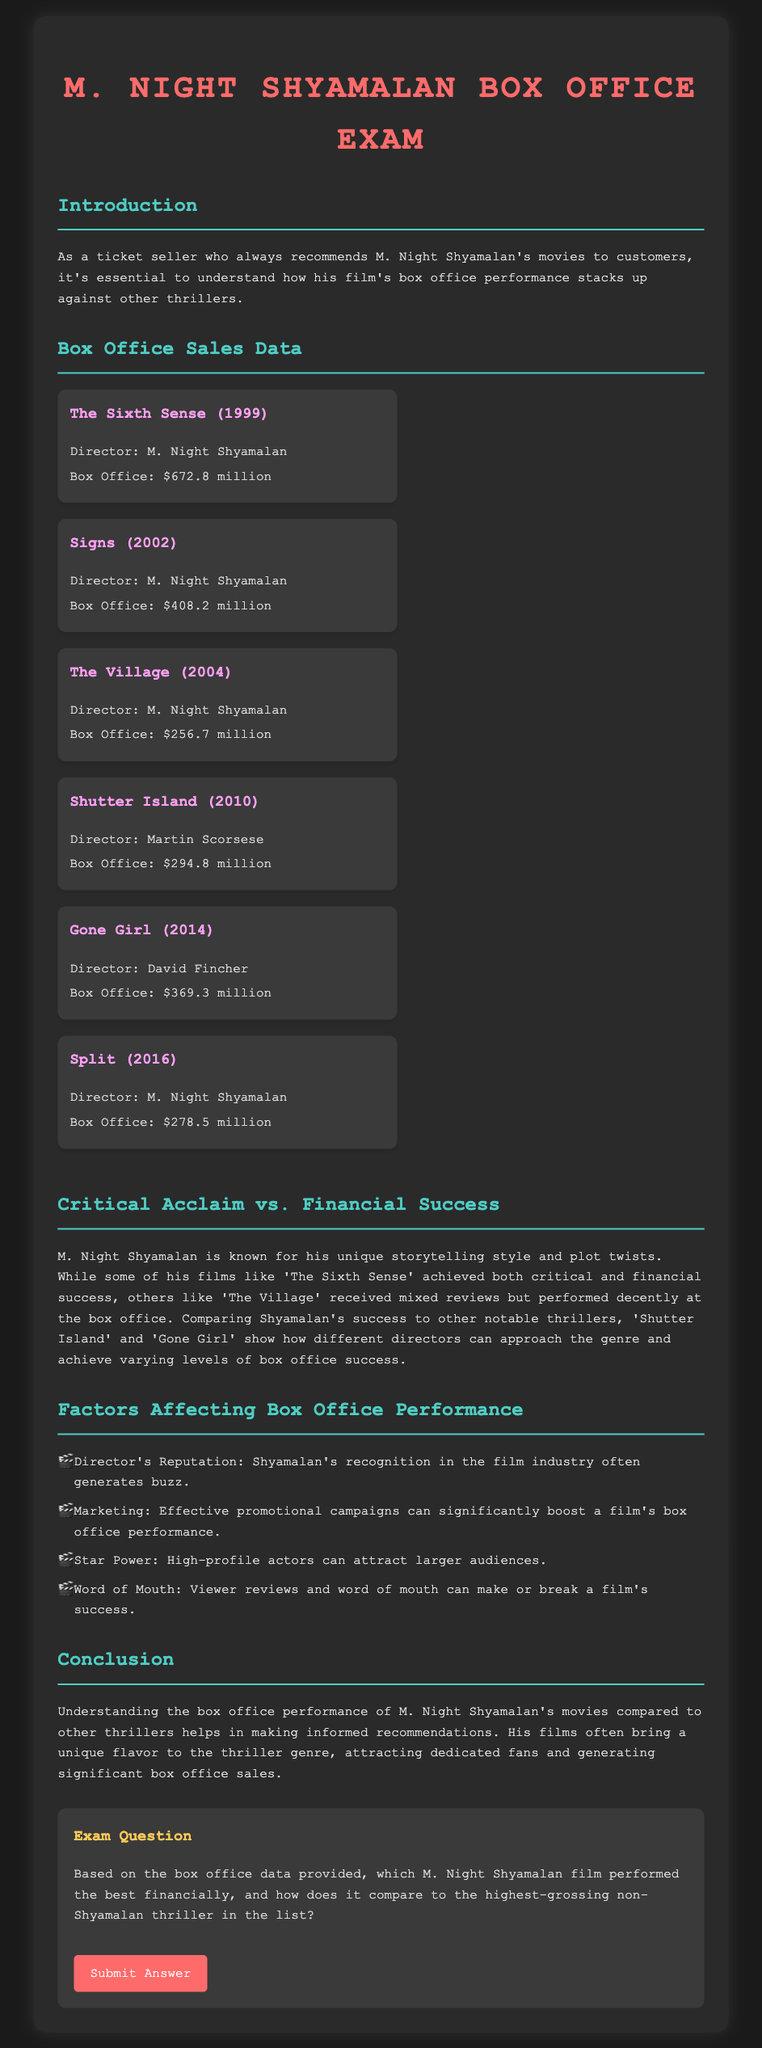What is the box office revenue of The Sixth Sense? The box office revenue for The Sixth Sense is explicitly mentioned in the document as $672.8 million.
Answer: $672.8 million Which director made the movie Signs? The director of Signs is listed in the document as M. Night Shyamalan.
Answer: M. Night Shyamalan What is the box office gross of Shutter Island? The document states that Shutter Island grossed $294.8 million at the box office.
Answer: $294.8 million How does Split's box office compare to The Village? The box office for Split is $278.5 million, while The Village's is $256.7 million, indicating Split performed better.
Answer: Better What factors are mentioned as affecting box office performance? The document lists factors affecting box office performance such as director's reputation, marketing, star power, and word of mouth.
Answer: Director's reputation, marketing, star power, word of mouth Which film achieved both critical and financial success? The document indicates that The Sixth Sense achieved both critical and financial success.
Answer: The Sixth Sense What is the highest-grossing non-Shyamalan thriller in the list? According to the box office data, the highest-grossing non-Shyamalan thriller is Shutter Island.
Answer: Shutter Island What is the box office revenue for Gone Girl? The box office revenue for Gone Girl is provided as $369.3 million in the document.
Answer: $369.3 million 